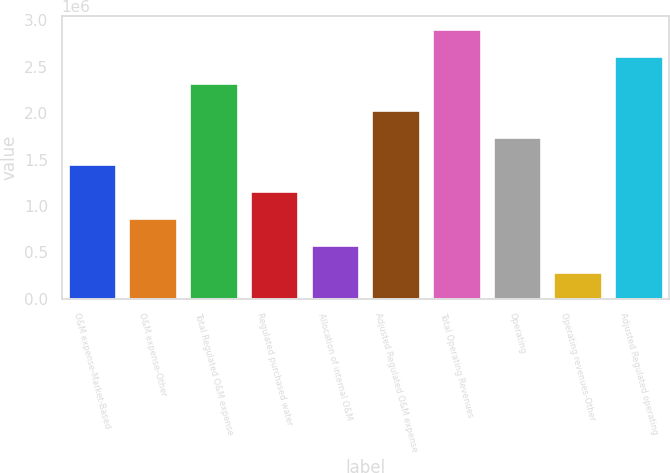<chart> <loc_0><loc_0><loc_500><loc_500><bar_chart><fcel>O&M expense-Market-Based<fcel>O&M expense-Other<fcel>Total Regulated O&M expense<fcel>Regulated purchased water<fcel>Allocation of internal O&M<fcel>Adjusted Regulated O&M expense<fcel>Total Operating Revenues<fcel>Operating<fcel>Operating revenues-Other<fcel>Adjusted Regulated operating<nl><fcel>1.45095e+06<fcel>870584<fcel>2.32149e+06<fcel>1.16077e+06<fcel>580403<fcel>2.03131e+06<fcel>2.90186e+06<fcel>1.74113e+06<fcel>290221<fcel>2.61168e+06<nl></chart> 